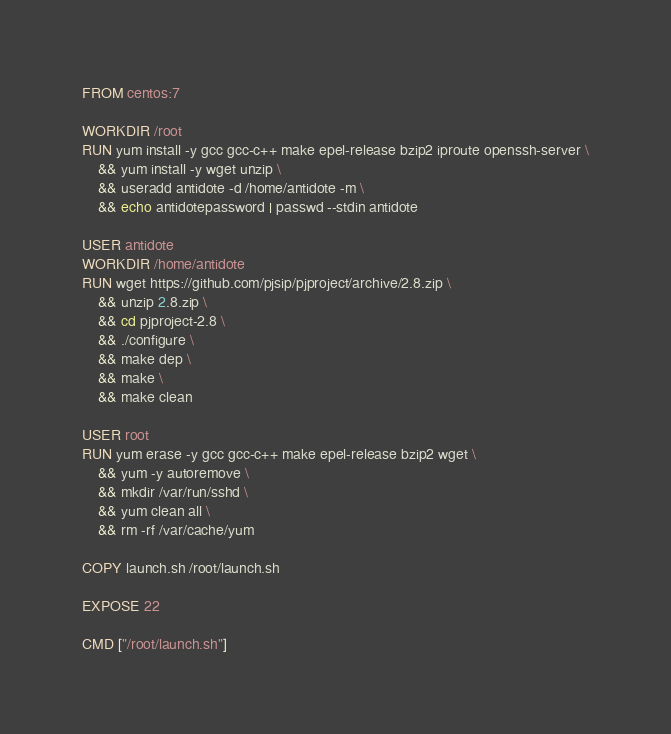<code> <loc_0><loc_0><loc_500><loc_500><_Dockerfile_>FROM centos:7

WORKDIR /root
RUN yum install -y gcc gcc-c++ make epel-release bzip2 iproute openssh-server \
    && yum install -y wget unzip \
    && useradd antidote -d /home/antidote -m \
    && echo antidotepassword | passwd --stdin antidote

USER antidote
WORKDIR /home/antidote
RUN wget https://github.com/pjsip/pjproject/archive/2.8.zip \
    && unzip 2.8.zip \
    && cd pjproject-2.8 \
    && ./configure \
    && make dep \
    && make \
    && make clean

USER root
RUN yum erase -y gcc gcc-c++ make epel-release bzip2 wget \
    && yum -y autoremove \
    && mkdir /var/run/sshd \
    && yum clean all \
    && rm -rf /var/cache/yum

COPY launch.sh /root/launch.sh

EXPOSE 22

CMD ["/root/launch.sh"]
</code> 